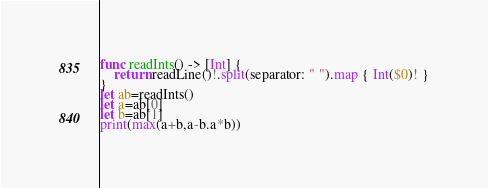<code> <loc_0><loc_0><loc_500><loc_500><_Swift_>func readInts() -> [Int] {
    return readLine()!.split(separator: " ").map { Int($0)! }
}
let ab=readInts()
let a=ab[0]
let b=ab[1]
print(max(a+b,a-b.a*b))</code> 